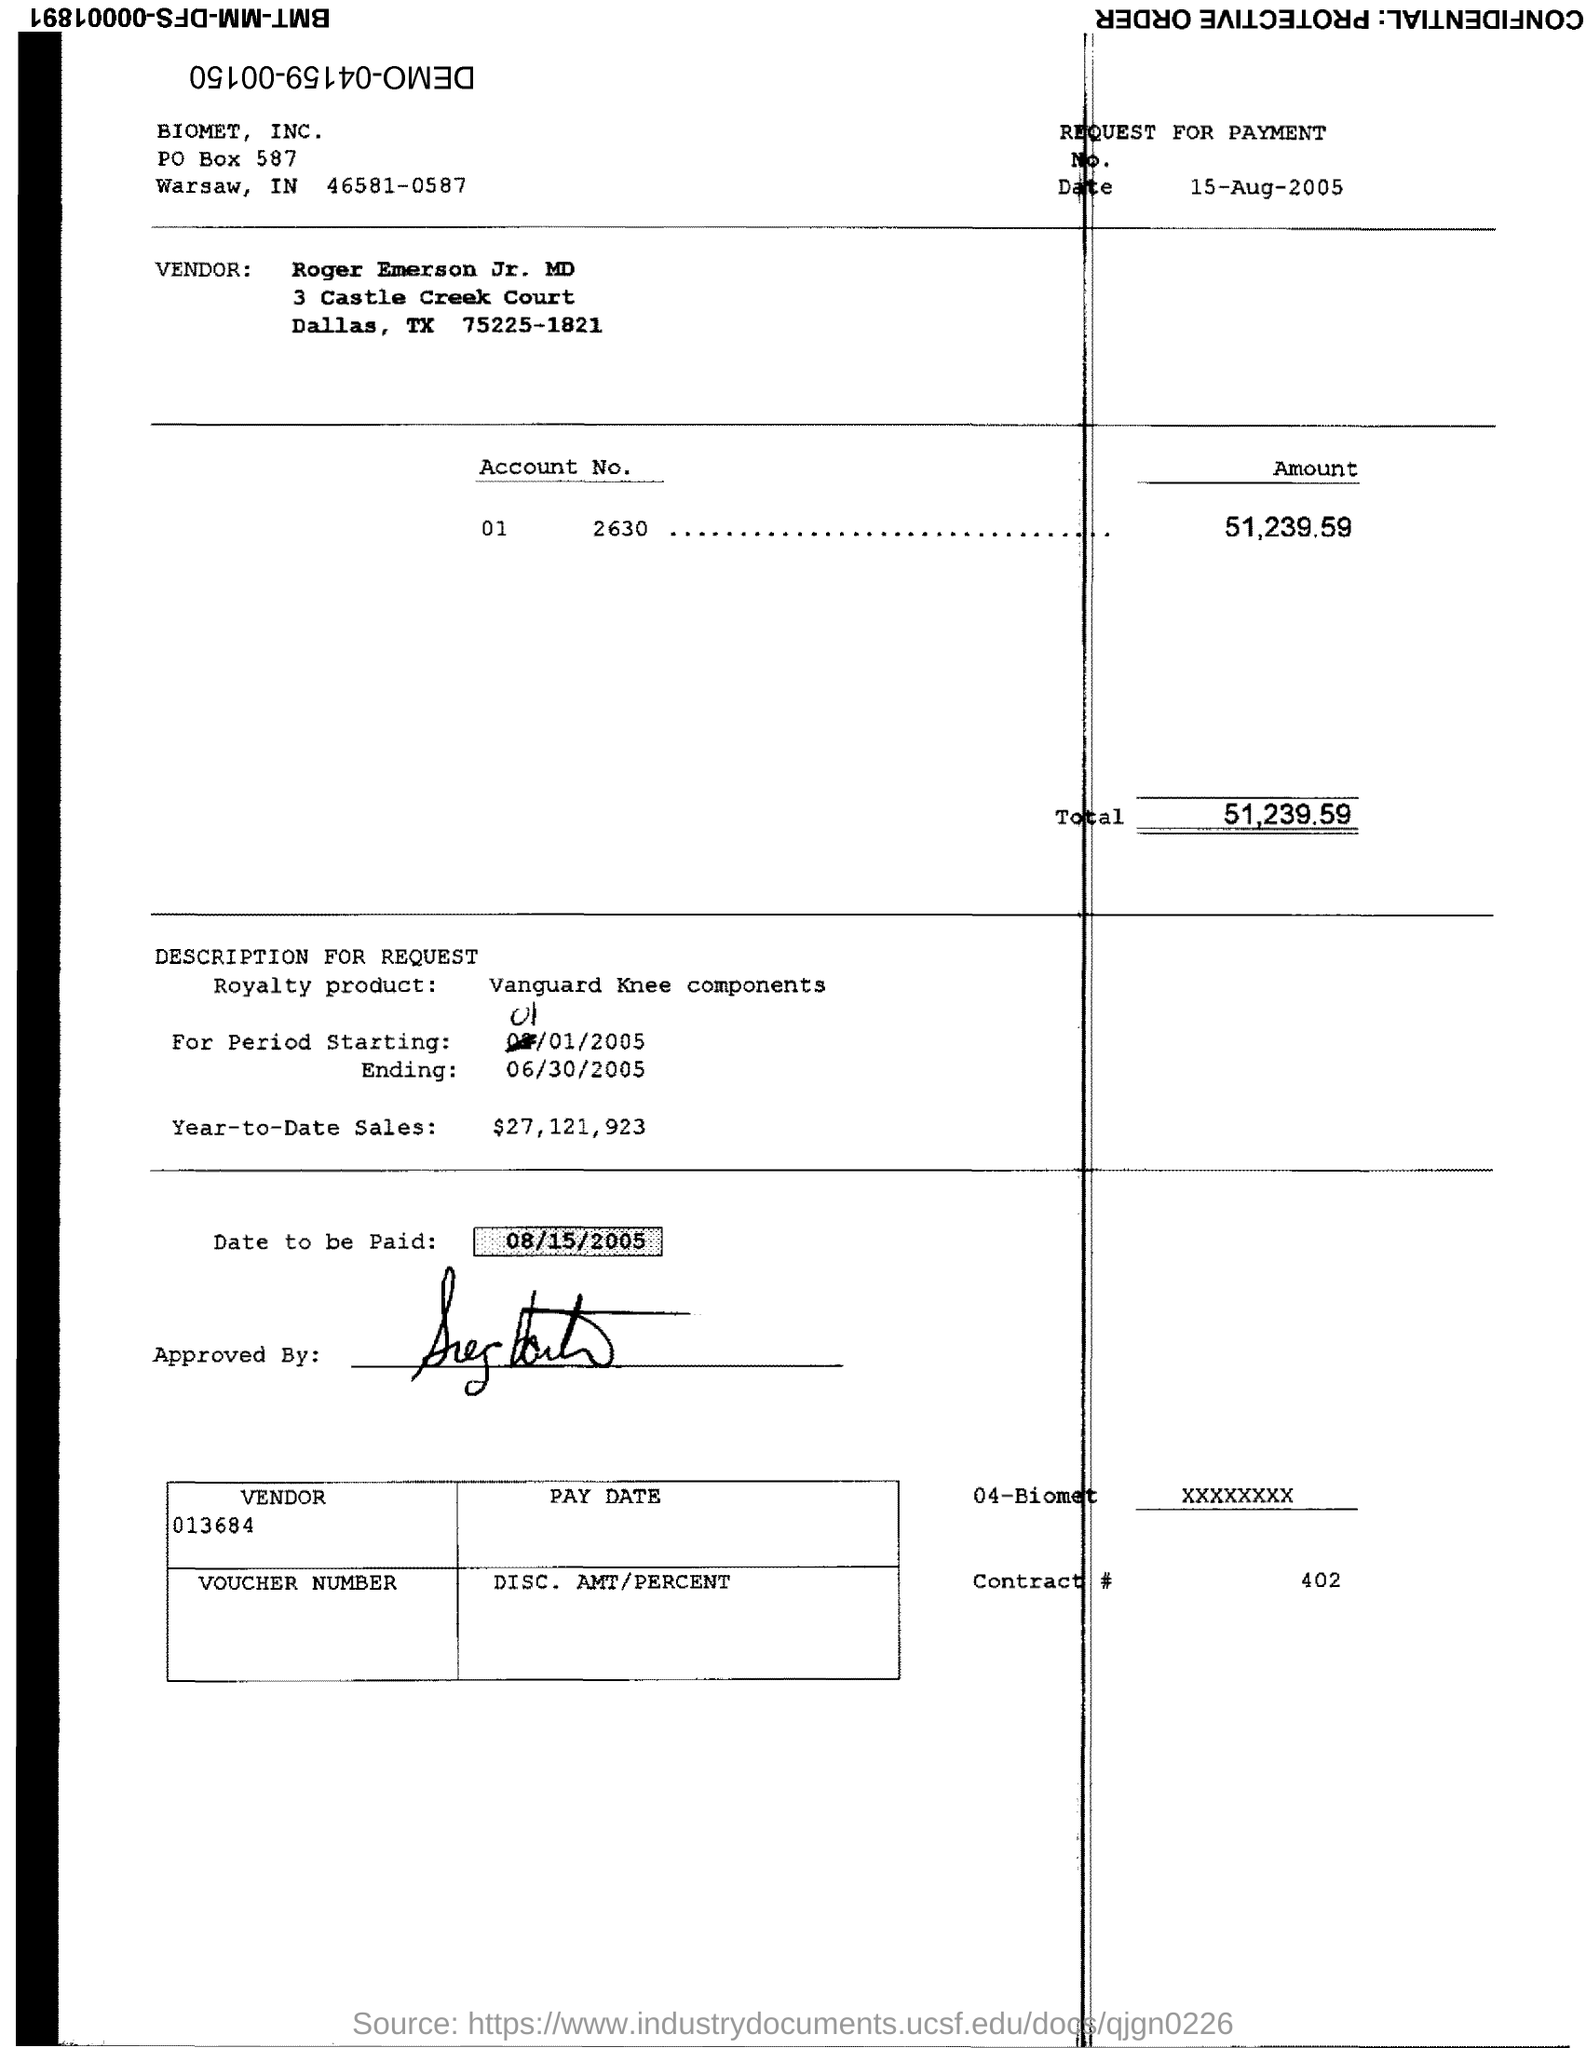What is the date to be paid?
Keep it short and to the point. 08/15/2005. What is the Total?
Make the answer very short. 51,239.59. 